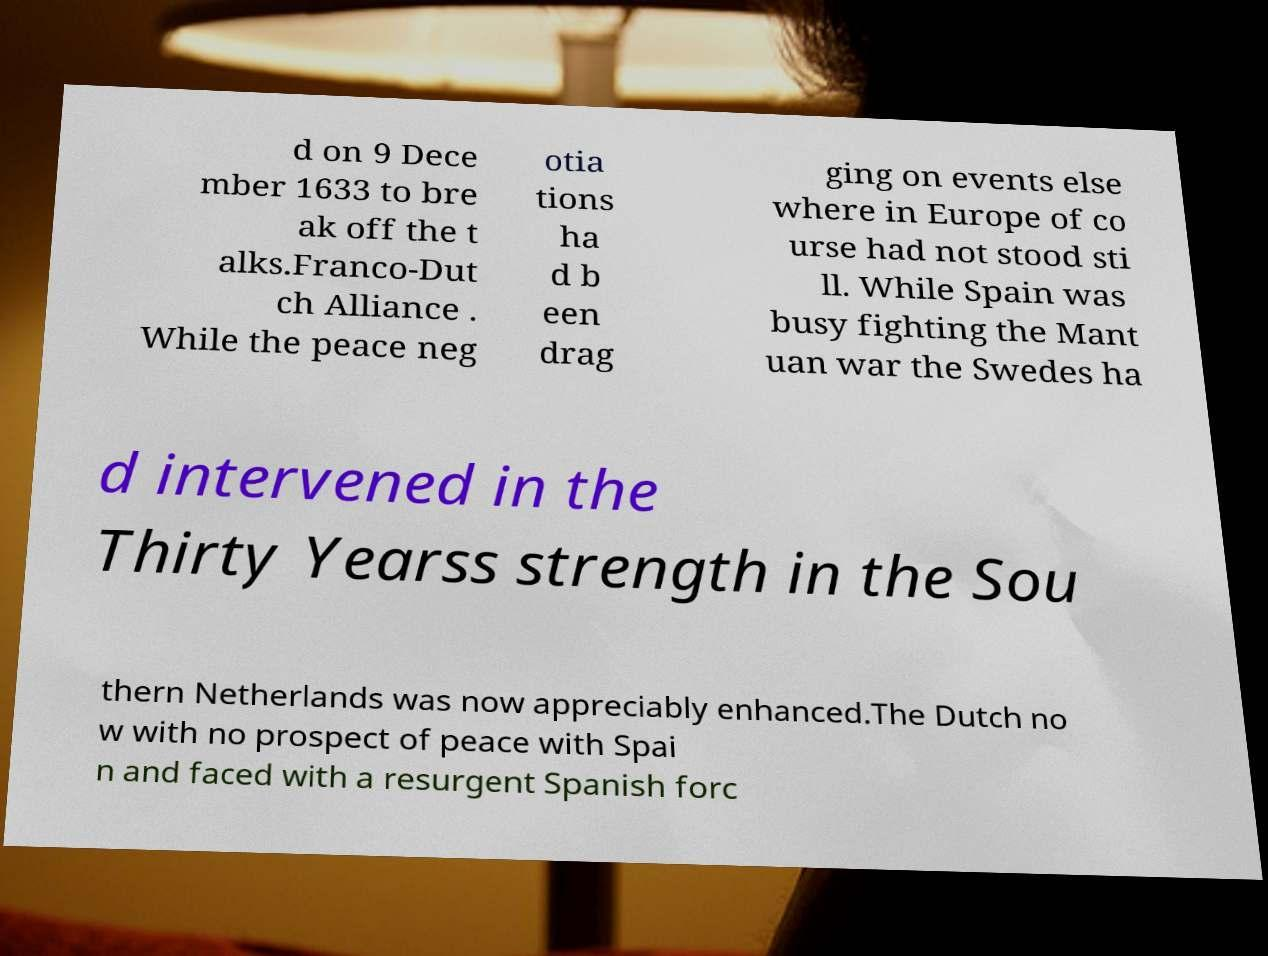I need the written content from this picture converted into text. Can you do that? d on 9 Dece mber 1633 to bre ak off the t alks.Franco-Dut ch Alliance . While the peace neg otia tions ha d b een drag ging on events else where in Europe of co urse had not stood sti ll. While Spain was busy fighting the Mant uan war the Swedes ha d intervened in the Thirty Yearss strength in the Sou thern Netherlands was now appreciably enhanced.The Dutch no w with no prospect of peace with Spai n and faced with a resurgent Spanish forc 